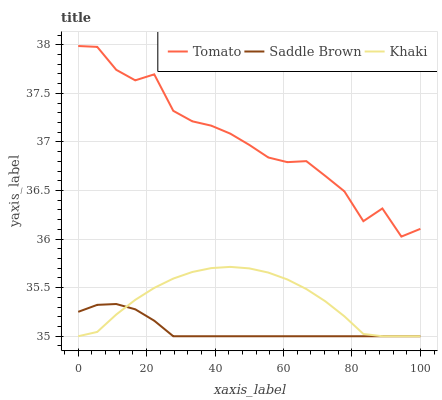Does Saddle Brown have the minimum area under the curve?
Answer yes or no. Yes. Does Tomato have the maximum area under the curve?
Answer yes or no. Yes. Does Khaki have the minimum area under the curve?
Answer yes or no. No. Does Khaki have the maximum area under the curve?
Answer yes or no. No. Is Saddle Brown the smoothest?
Answer yes or no. Yes. Is Tomato the roughest?
Answer yes or no. Yes. Is Khaki the smoothest?
Answer yes or no. No. Is Khaki the roughest?
Answer yes or no. No. Does Tomato have the highest value?
Answer yes or no. Yes. Does Khaki have the highest value?
Answer yes or no. No. Is Khaki less than Tomato?
Answer yes or no. Yes. Is Tomato greater than Saddle Brown?
Answer yes or no. Yes. Does Saddle Brown intersect Khaki?
Answer yes or no. Yes. Is Saddle Brown less than Khaki?
Answer yes or no. No. Is Saddle Brown greater than Khaki?
Answer yes or no. No. Does Khaki intersect Tomato?
Answer yes or no. No. 